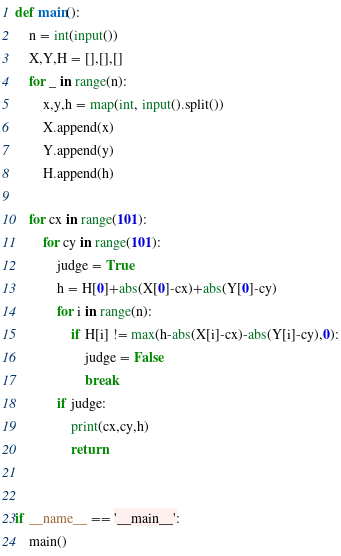Convert code to text. <code><loc_0><loc_0><loc_500><loc_500><_Python_>def main():
    n = int(input())
    X,Y,H = [],[],[]
    for _ in range(n):
        x,y,h = map(int, input().split())
        X.append(x)
        Y.append(y)
        H.append(h)

    for cx in range(101):
        for cy in range(101):
            judge = True
            h = H[0]+abs(X[0]-cx)+abs(Y[0]-cy)
            for i in range(n):
                if H[i] != max(h-abs(X[i]-cx)-abs(Y[i]-cy),0):
                    judge = False
                    break
            if judge:
                print(cx,cy,h)
                return


if __name__ == '__main__':
    main()
</code> 